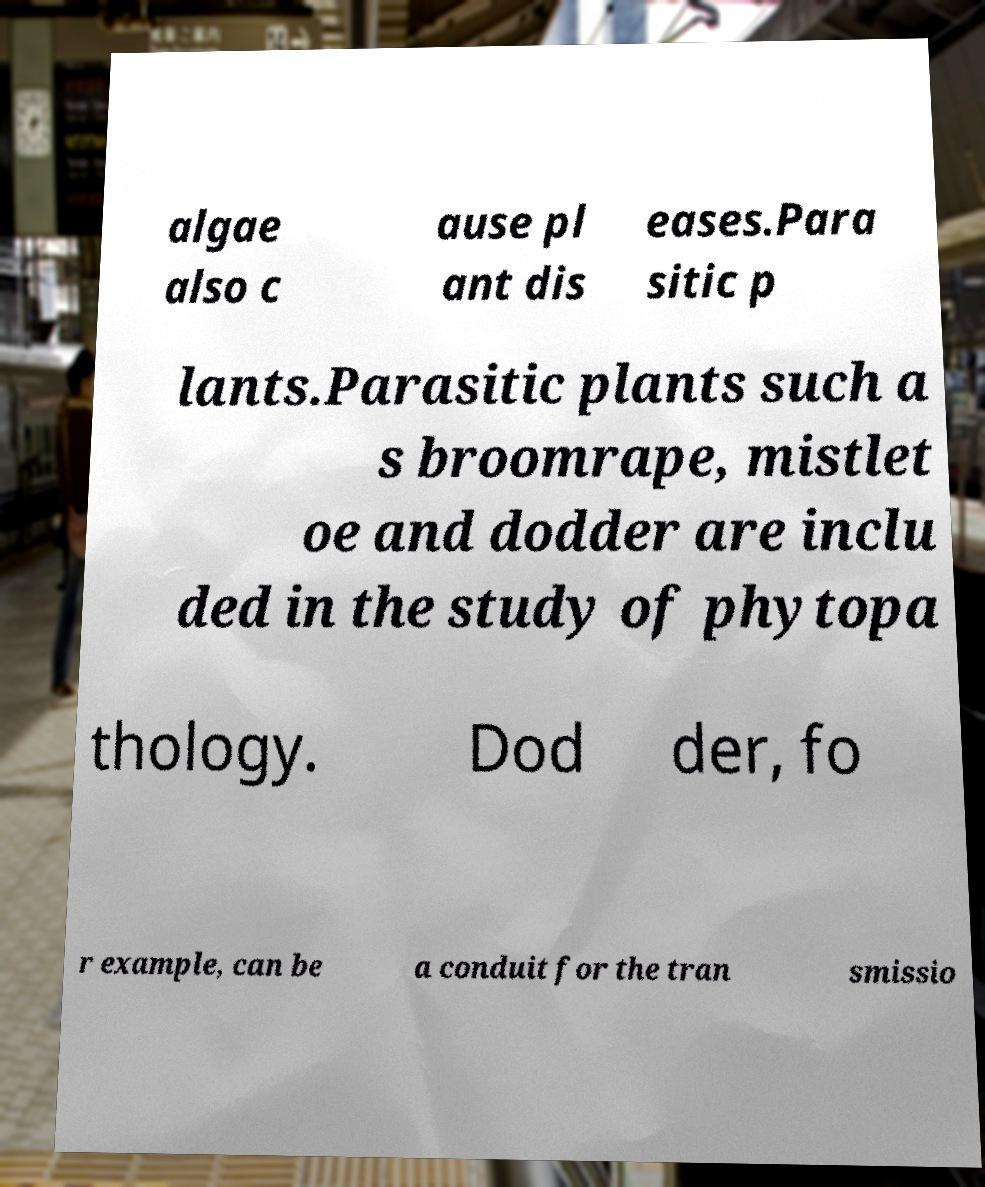Please read and relay the text visible in this image. What does it say? algae also c ause pl ant dis eases.Para sitic p lants.Parasitic plants such a s broomrape, mistlet oe and dodder are inclu ded in the study of phytopa thology. Dod der, fo r example, can be a conduit for the tran smissio 